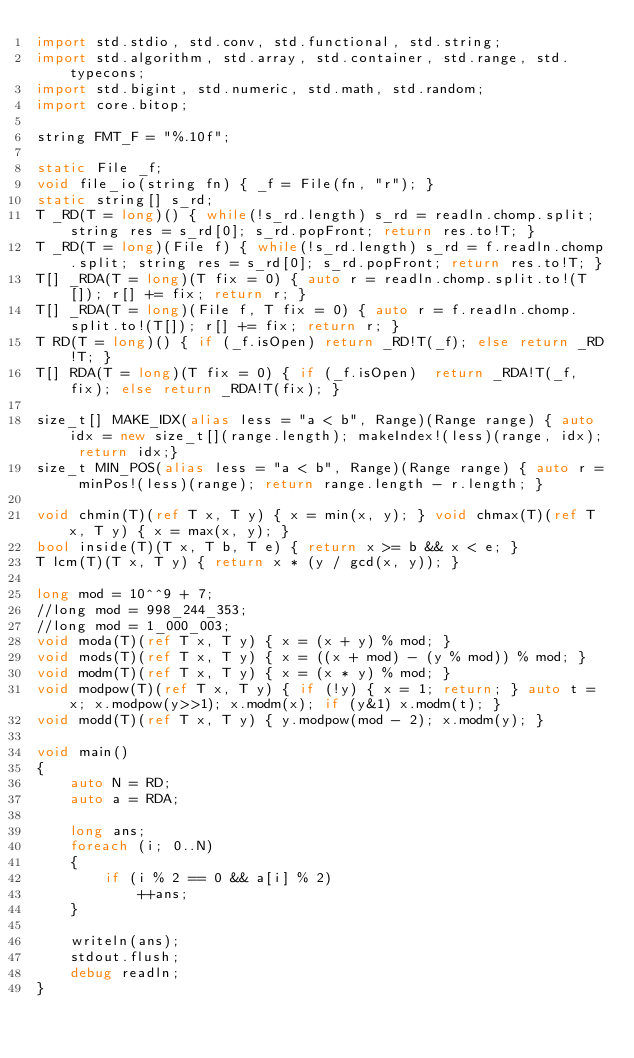Convert code to text. <code><loc_0><loc_0><loc_500><loc_500><_D_>import std.stdio, std.conv, std.functional, std.string;
import std.algorithm, std.array, std.container, std.range, std.typecons;
import std.bigint, std.numeric, std.math, std.random;
import core.bitop;

string FMT_F = "%.10f";

static File _f;
void file_io(string fn) { _f = File(fn, "r"); }
static string[] s_rd;
T _RD(T = long)() { while(!s_rd.length) s_rd = readln.chomp.split; string res = s_rd[0]; s_rd.popFront; return res.to!T; }
T _RD(T = long)(File f) { while(!s_rd.length) s_rd = f.readln.chomp.split; string res = s_rd[0]; s_rd.popFront; return res.to!T; }
T[] _RDA(T = long)(T fix = 0) { auto r = readln.chomp.split.to!(T[]); r[] += fix; return r; }
T[] _RDA(T = long)(File f, T fix = 0) { auto r = f.readln.chomp.split.to!(T[]); r[] += fix; return r; }
T RD(T = long)() { if (_f.isOpen) return _RD!T(_f); else return _RD!T; }
T[] RDA(T = long)(T fix = 0) { if (_f.isOpen)  return _RDA!T(_f, fix); else return _RDA!T(fix); }

size_t[] MAKE_IDX(alias less = "a < b", Range)(Range range) { auto idx = new size_t[](range.length); makeIndex!(less)(range, idx); return idx;}
size_t MIN_POS(alias less = "a < b", Range)(Range range) { auto r = minPos!(less)(range); return range.length - r.length; }

void chmin(T)(ref T x, T y) { x = min(x, y); } void chmax(T)(ref T x, T y) { x = max(x, y); }
bool inside(T)(T x, T b, T e) { return x >= b && x < e; }
T lcm(T)(T x, T y) { return x * (y / gcd(x, y)); }

long mod = 10^^9 + 7;
//long mod = 998_244_353;
//long mod = 1_000_003;
void moda(T)(ref T x, T y) { x = (x + y) % mod; }
void mods(T)(ref T x, T y) { x = ((x + mod) - (y % mod)) % mod; }
void modm(T)(ref T x, T y) { x = (x * y) % mod; }
void modpow(T)(ref T x, T y) { if (!y) { x = 1; return; } auto t = x; x.modpow(y>>1); x.modm(x); if (y&1) x.modm(t); }
void modd(T)(ref T x, T y) { y.modpow(mod - 2); x.modm(y); }

void main()
{
	auto N = RD;
	auto a = RDA;

	long ans;
	foreach (i; 0..N)
	{
		if (i % 2 == 0 && a[i] % 2)
			++ans;
	}

	writeln(ans);
	stdout.flush;
	debug readln;
}</code> 